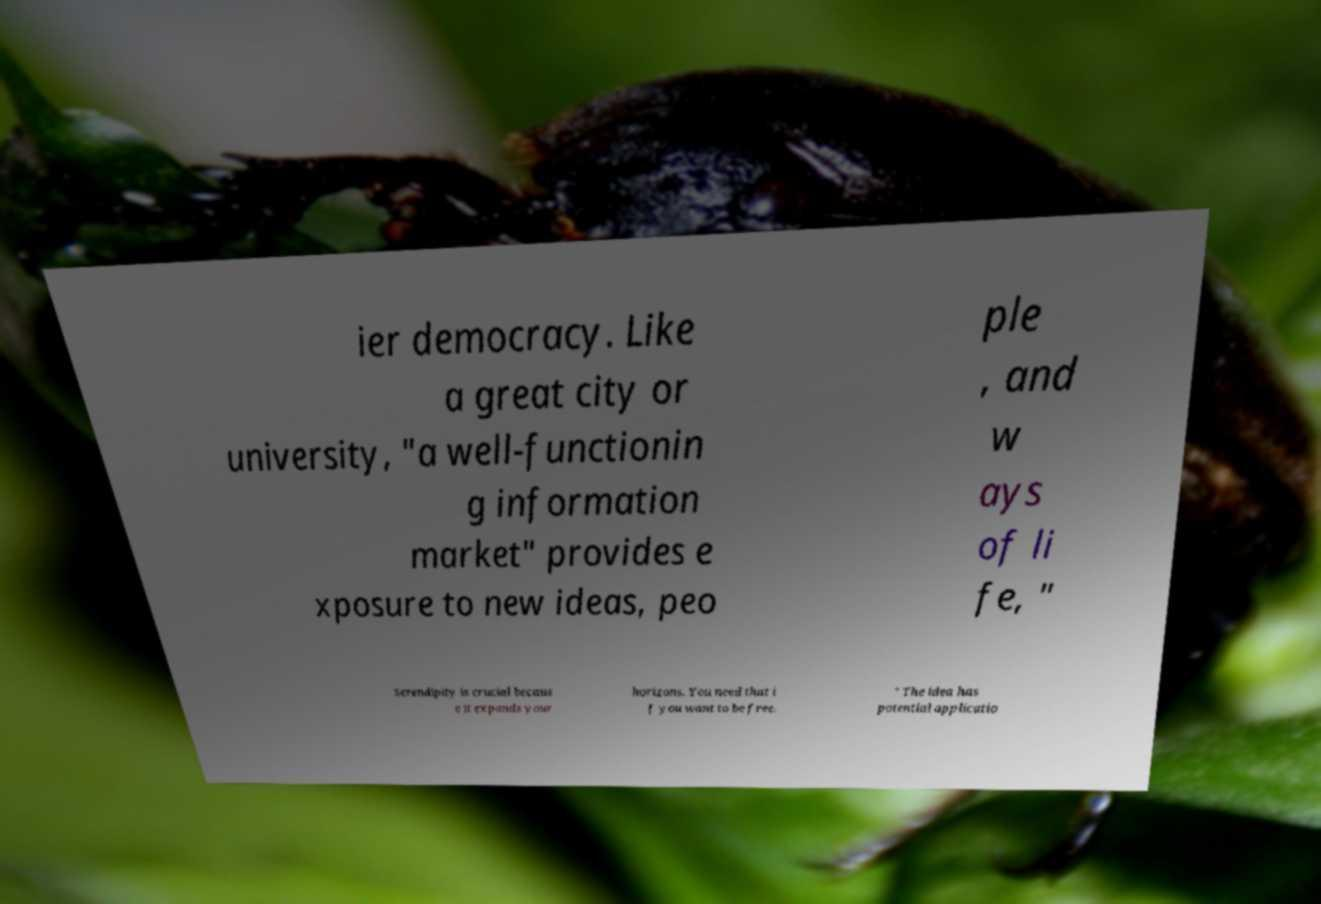Can you accurately transcribe the text from the provided image for me? ier democracy. Like a great city or university, "a well-functionin g information market" provides e xposure to new ideas, peo ple , and w ays of li fe, " Serendipity is crucial becaus e it expands your horizons. You need that i f you want to be free. " The idea has potential applicatio 